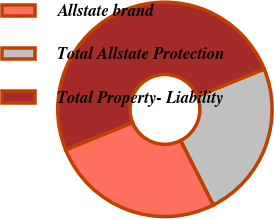Convert chart. <chart><loc_0><loc_0><loc_500><loc_500><pie_chart><fcel>Allstate brand<fcel>Total Allstate Protection<fcel>Total Property- Liability<nl><fcel>26.32%<fcel>23.68%<fcel>50.0%<nl></chart> 